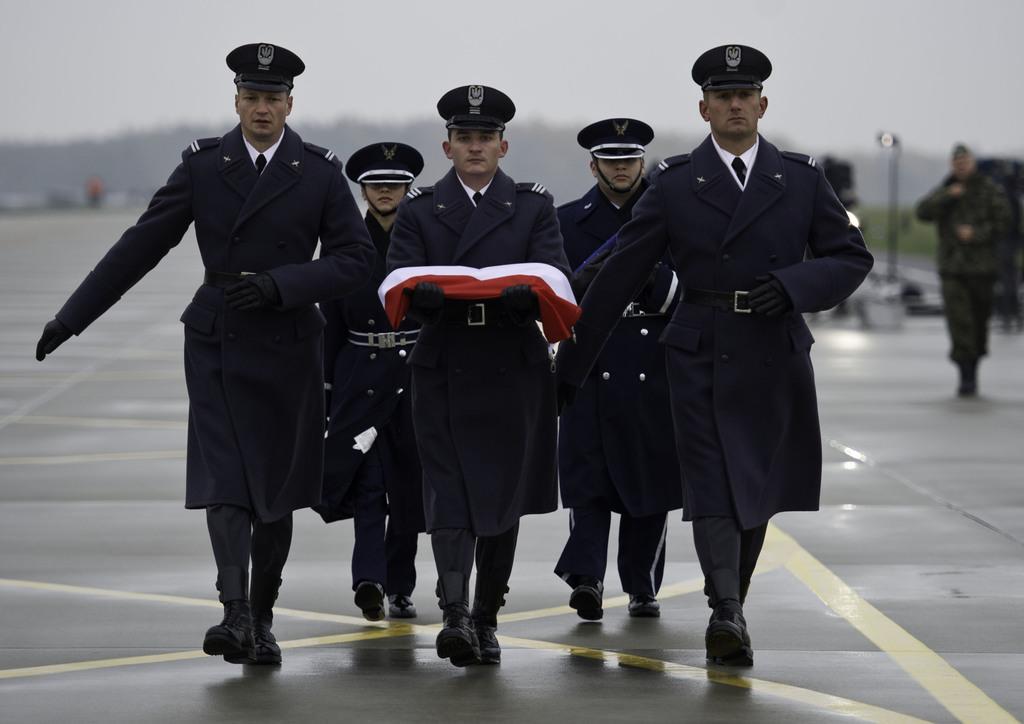Can you describe this image briefly? In this image I can see in the middle a group of people are walking, they are wearing coats, caps. In the middle there is a person holding, it looks like a cloth in white and orange color. At the top there is the sky. 